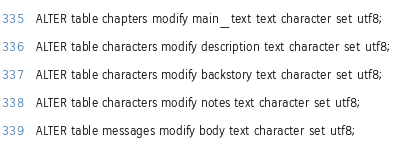Convert code to text. <code><loc_0><loc_0><loc_500><loc_500><_SQL_>ALTER table chapters modify main_text text character set utf8;
ALTER table characters modify description text character set utf8;
ALTER table characters modify backstory text character set utf8;
ALTER table characters modify notes text character set utf8;
ALTER table messages modify body text character set utf8;
</code> 